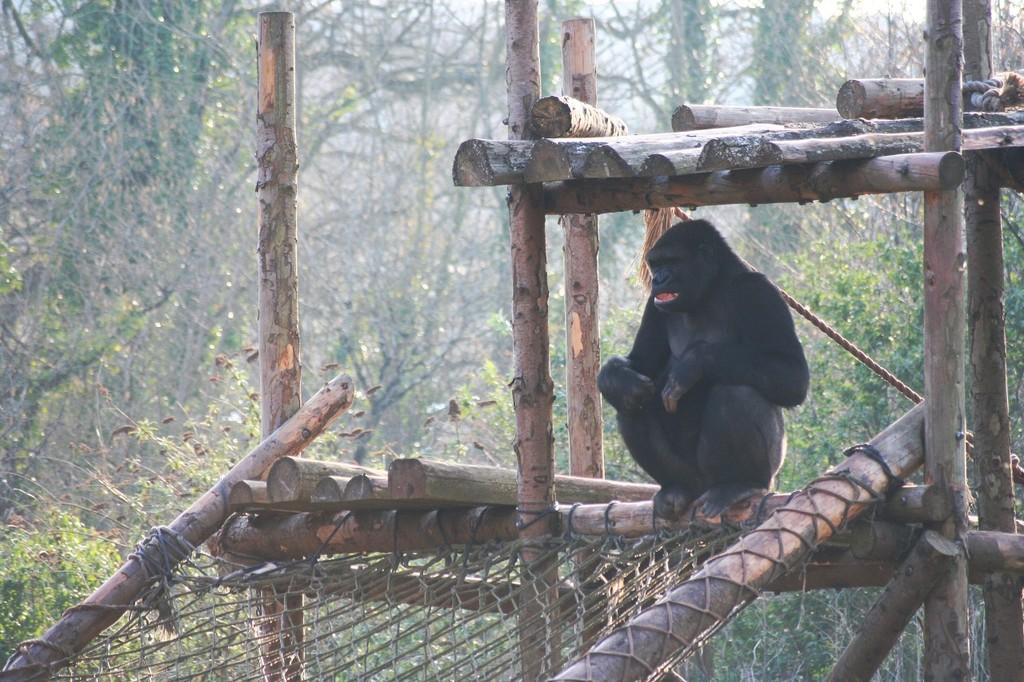What animal is present in the image? There is a monkey in the image. Where is the monkey located? The monkey is sitting in a wooden shed. What can be seen in the background of the image? There are trees visible in the background of the image. How many chairs are present in the image? There are no chairs visible in the image. 